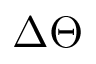Convert formula to latex. <formula><loc_0><loc_0><loc_500><loc_500>\Delta \Theta</formula> 